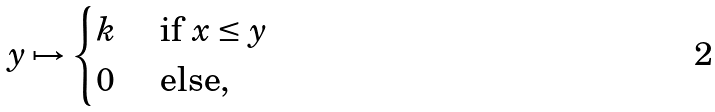Convert formula to latex. <formula><loc_0><loc_0><loc_500><loc_500>y \mapsto \begin{cases} k & \text { if } x \leq y \\ 0 & \text { else} , \end{cases}</formula> 